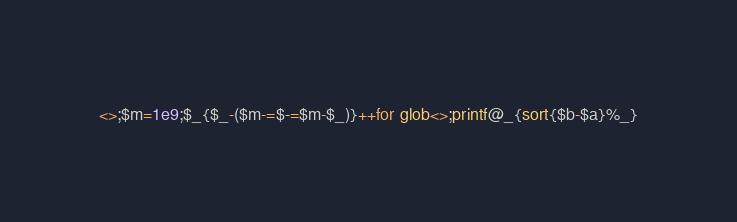Convert code to text. <code><loc_0><loc_0><loc_500><loc_500><_Perl_><>;$m=1e9;$_{$_-($m-=$-=$m-$_)}++for glob<>;printf@_{sort{$b-$a}%_}</code> 